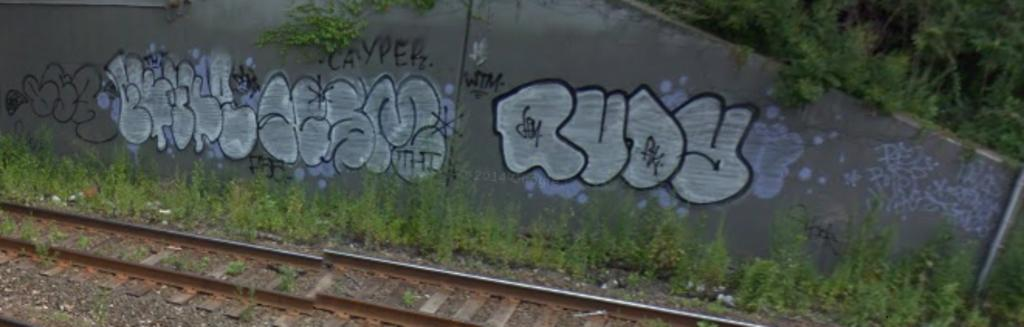Provide a one-sentence caption for the provided image. A dilapidated train track with graffiti on the walls that says Rudy. 